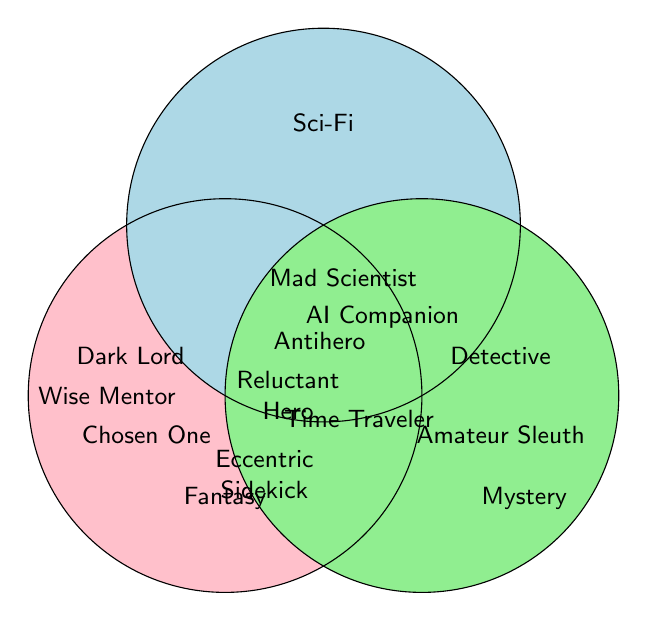What are the character archetypes unique to Fantasy? Look at the section of the Venn diagram only covered by the Fantasy circle. These archetypes are Wise Mentor, Chosen One, Dark Lord, and Trickster.
Answer: Wise Mentor, Chosen One, Dark Lord, Trickster Which character archetype appears in all three genres? Identify the character archetype in the center where all three circles overlap. The only archetype there is Antihero.
Answer: Antihero How many genres feature the Reluctant Hero archetype? Reluctant Hero is in the overlap area between Fantasy and Science Fiction, denoting two genres.
Answer: 2 Is the Time Traveler archetype present in the Fantasy genre? Look at the overlap between Science Fiction and Mystery genres to identify where the Time Traveler archetype appears. It is not in the Fantasy circle.
Answer: No What genres feature the Eccentric Sidekick archetype? Eccentric Sidekick is in the overlap between Fantasy and Mystery, indicating both these genres feature it.
Answer: Fantasy and Mystery Are there more unique character archetypes in Fantasy or Science Fiction? Count the unique archetypes for Fantasy (4: Wise Mentor, Chosen One, Dark Lord, Trickster) and Science Fiction (3: Mad Scientist, AI Companion, Space Captain). Fantasy has more unique archetypes.
Answer: Fantasy Which genre has the Femme Fatale archetype? Femme Fatale is in the overlap between Fantasy and Science Fiction, indicating both genres feature it.
Answer: Fantasy and Science Fiction Does the Amateur Sleuth archetype overlap with any other genres? Amateur Sleuth is solely in the Mystery circle with no overlap, indicating it does not belong to other genres.
Answer: No What character archetype occurs in both Science Fiction and Mystery but not in Fantasy? Identify the archetype in the overlap between Science Fiction and Mystery but not in Fantasy. This is the Time Traveler.
Answer: Time Traveler 